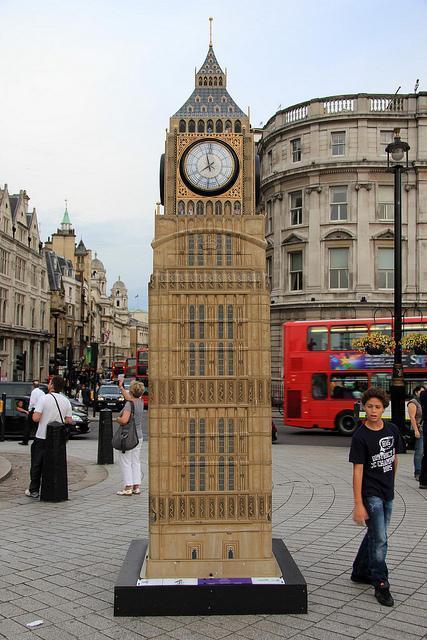What is actually the tallest object in the picture?
Answer the question by selecting the correct answer among the 4 following choices.
Options: Boy, buildings, bus, clock tower. Buildings. 